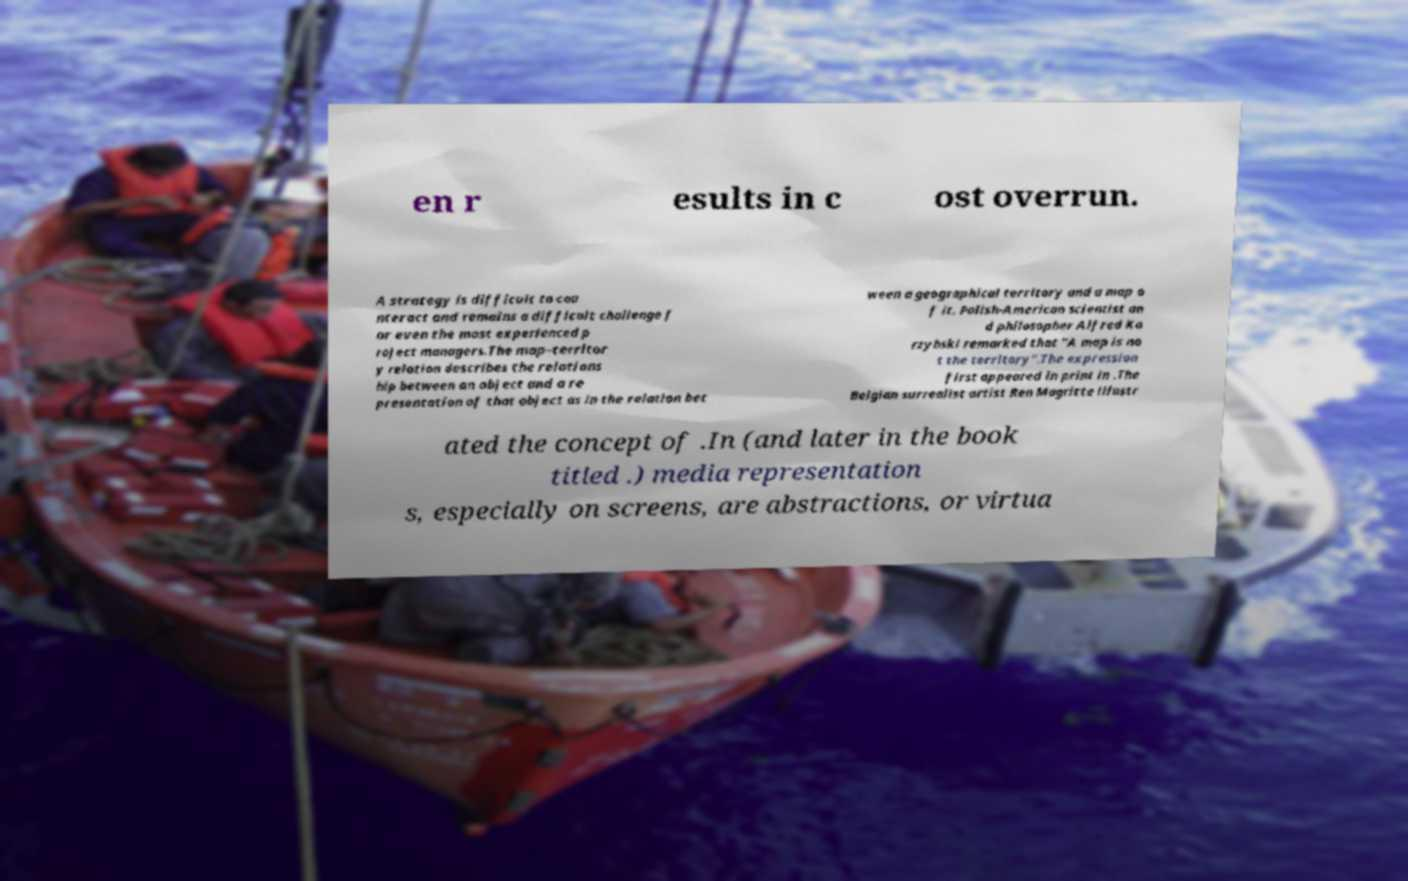What messages or text are displayed in this image? I need them in a readable, typed format. en r esults in c ost overrun. A strategy is difficult to cou nteract and remains a difficult challenge f or even the most experienced p roject managers.The map–territor y relation describes the relations hip between an object and a re presentation of that object as in the relation bet ween a geographical territory and a map o f it. Polish-American scientist an d philosopher Alfred Ko rzybski remarked that "A map is no t the territory".The expression first appeared in print in .The Belgian surrealist artist Ren Magritte illustr ated the concept of .In (and later in the book titled .) media representation s, especially on screens, are abstractions, or virtua 